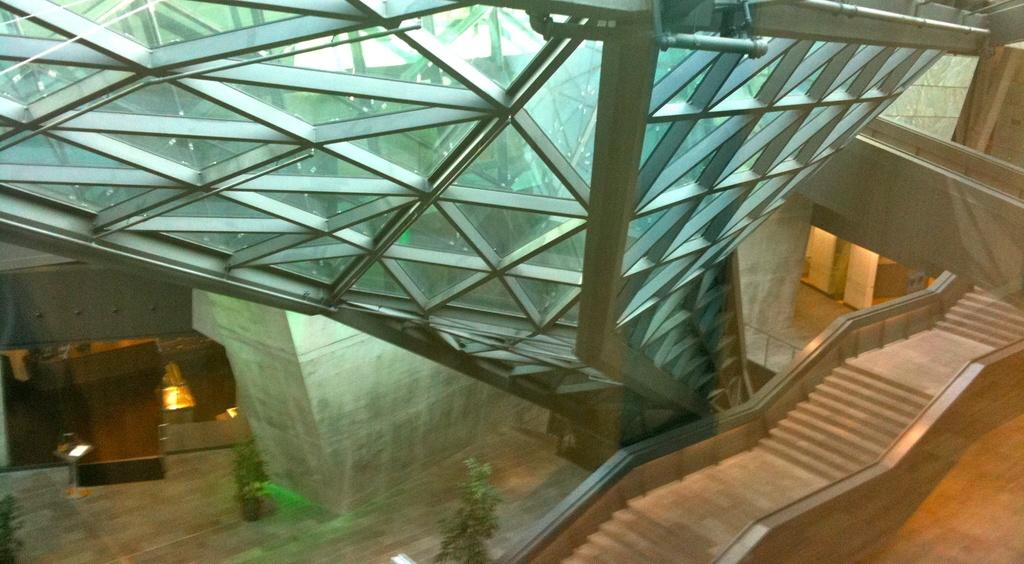What type of structure can be seen in the image? There are stairs in the image. What material appears to be used for a surface in the image? There is a glass surface in the image. What is located on the left side of the image? There are plants, tables, and lights on the left side of the image. What is the price of the goat in the image? There is no goat present in the image, so it is not possible to determine its price. 